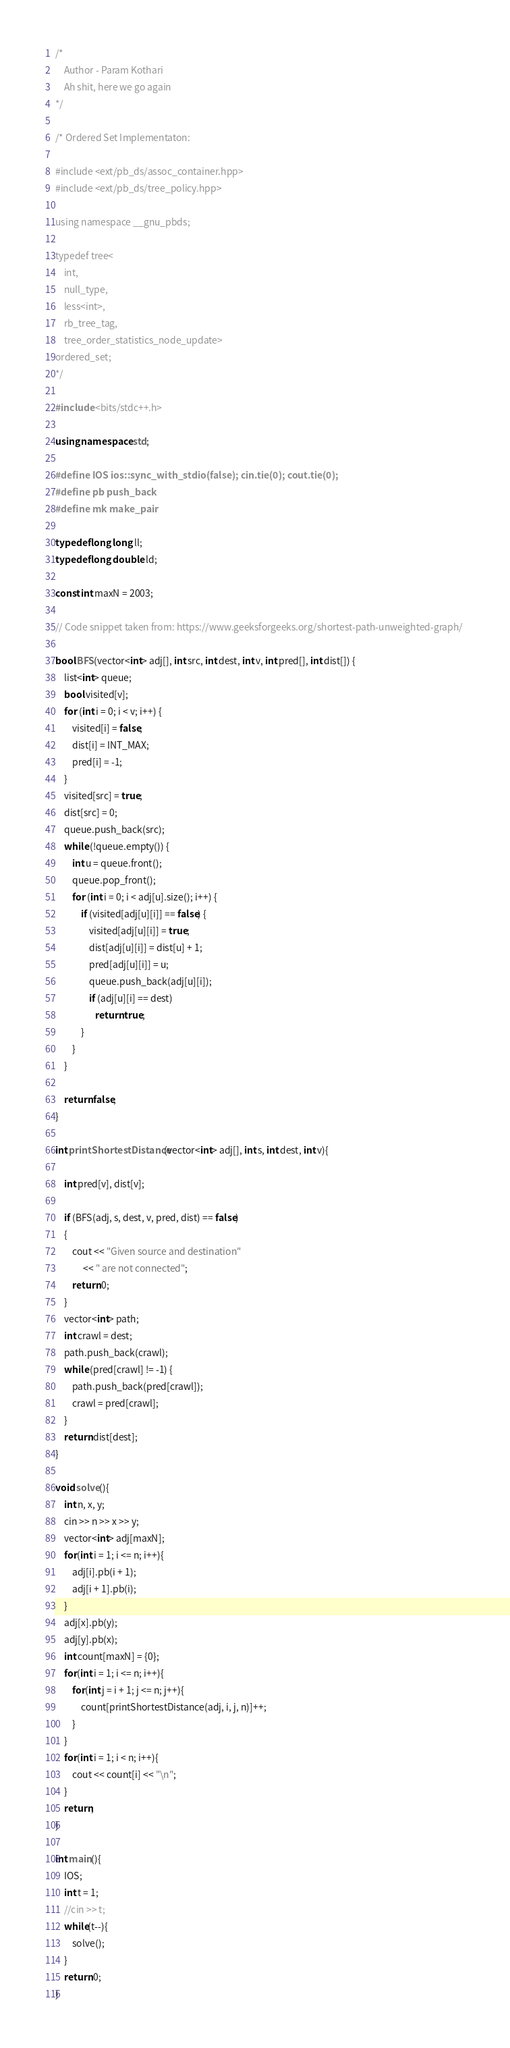Convert code to text. <code><loc_0><loc_0><loc_500><loc_500><_C++_>/*
    Author - Param Kothari
    Ah shit, here we go again
*/
 
/* Ordered Set Implementaton:

#include <ext/pb_ds/assoc_container.hpp> 
#include <ext/pb_ds/tree_policy.hpp> 

using namespace __gnu_pbds;

typedef tree<
    int,
    null_type,
    less<int>,
    rb_tree_tag,
    tree_order_statistics_node_update>
ordered_set;
*/

#include <bits/stdc++.h>
 
using namespace std;

#define IOS ios::sync_with_stdio(false); cin.tie(0); cout.tie(0);
#define pb push_back
#define mk make_pair 
 
typedef long long ll;
typedef long double ld;

const int maxN = 2003;

// Code snippet taken from: https://www.geeksforgeeks.org/shortest-path-unweighted-graph/ 

bool BFS(vector<int> adj[], int src, int dest, int v, int pred[], int dist[]) { 
    list<int> queue; 
    bool visited[v]; 
    for (int i = 0; i < v; i++) { 
        visited[i] = false; 
        dist[i] = INT_MAX; 
        pred[i] = -1; 
    } 
    visited[src] = true; 
    dist[src] = 0; 
    queue.push_back(src); 
    while (!queue.empty()) { 
        int u = queue.front(); 
        queue.pop_front(); 
        for (int i = 0; i < adj[u].size(); i++) { 
            if (visited[adj[u][i]] == false) { 
                visited[adj[u][i]] = true; 
                dist[adj[u][i]] = dist[u] + 1; 
                pred[adj[u][i]] = u; 
                queue.push_back(adj[u][i]); 
                if (adj[u][i] == dest) 
                   return true; 
            } 
        } 
    } 
  
    return false; 
} 

int printShortestDistance(vector<int> adj[], int s, int dest, int v){ 

    int pred[v], dist[v]; 
  
    if (BFS(adj, s, dest, v, pred, dist) == false) 
    { 
        cout << "Given source and destination"
             << " are not connected"; 
        return 0; 
    } 
    vector<int> path; 
    int crawl = dest; 
    path.push_back(crawl); 
    while (pred[crawl] != -1) { 
        path.push_back(pred[crawl]); 
        crawl = pred[crawl]; 
    }     
    return dist[dest];
}

void solve(){
    int n, x, y;
    cin >> n >> x >> y;
    vector<int> adj[maxN];
    for(int i = 1; i <= n; i++){
        adj[i].pb(i + 1);
        adj[i + 1].pb(i);
    }
    adj[x].pb(y);
    adj[y].pb(x);
    int count[maxN] = {0};
    for(int i = 1; i <= n; i++){
        for(int j = i + 1; j <= n; j++){
            count[printShortestDistance(adj, i, j, n)]++;
        }
    }
    for(int i = 1; i < n; i++){
        cout << count[i] << "\n";
    }
    return;
}
 
int main(){
    IOS;
    int t = 1;
    //cin >> t;
    while(t--){
        solve();
    }
    return 0;
}
</code> 